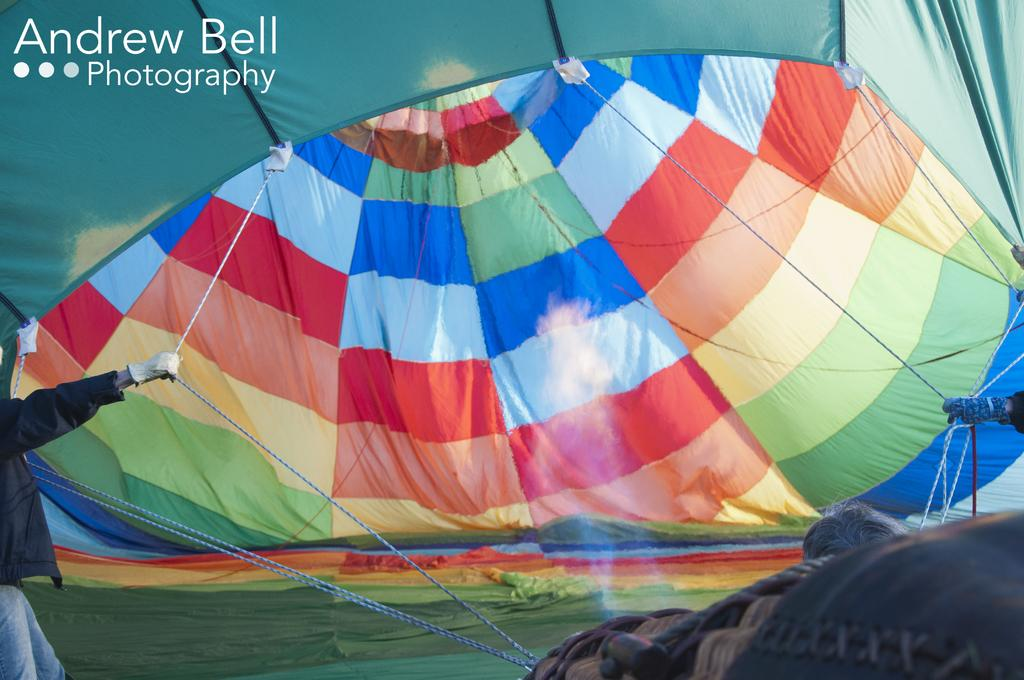What is the main subject of the image? There is a colorful hot air balloon in the image. What is the person in the image doing? A person is standing and holding a rope in the image. How is the person connected to the hot air balloon? The rope is tied to the hot air balloon, and the person is holding it. How many robins can be seen sitting on the hot air balloon in the image? There are no robins present in the image; it features a hot air balloon and a person holding a rope. What type of paper is being used to write on in the image? There is no paper visible in the image, as it primarily focuses on the hot air balloon and the person holding the rope. 